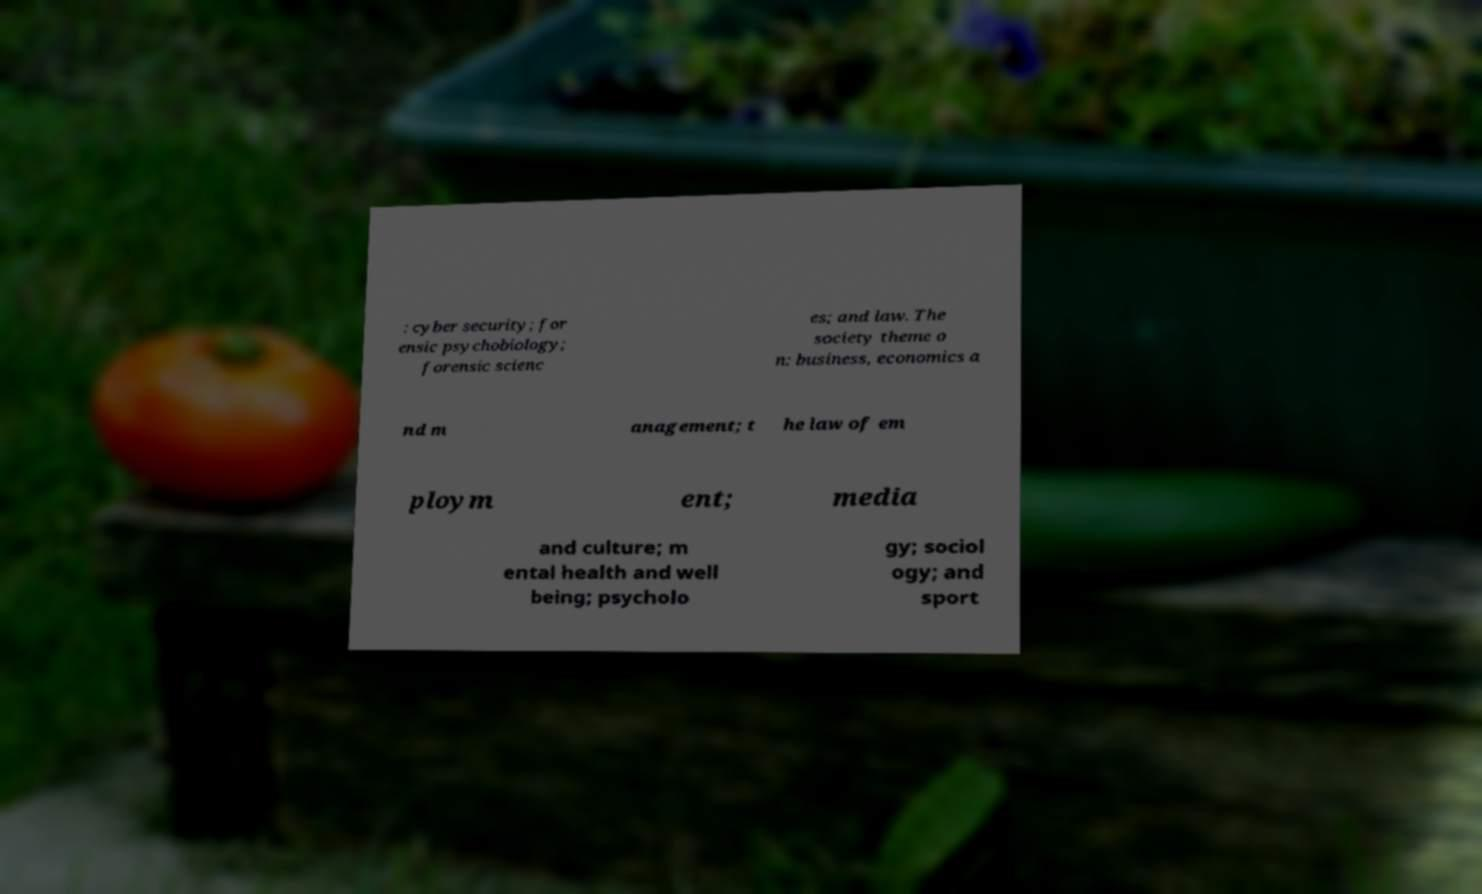Please identify and transcribe the text found in this image. : cyber security; for ensic psychobiology; forensic scienc es; and law. The society theme o n: business, economics a nd m anagement; t he law of em ploym ent; media and culture; m ental health and well being; psycholo gy; sociol ogy; and sport 